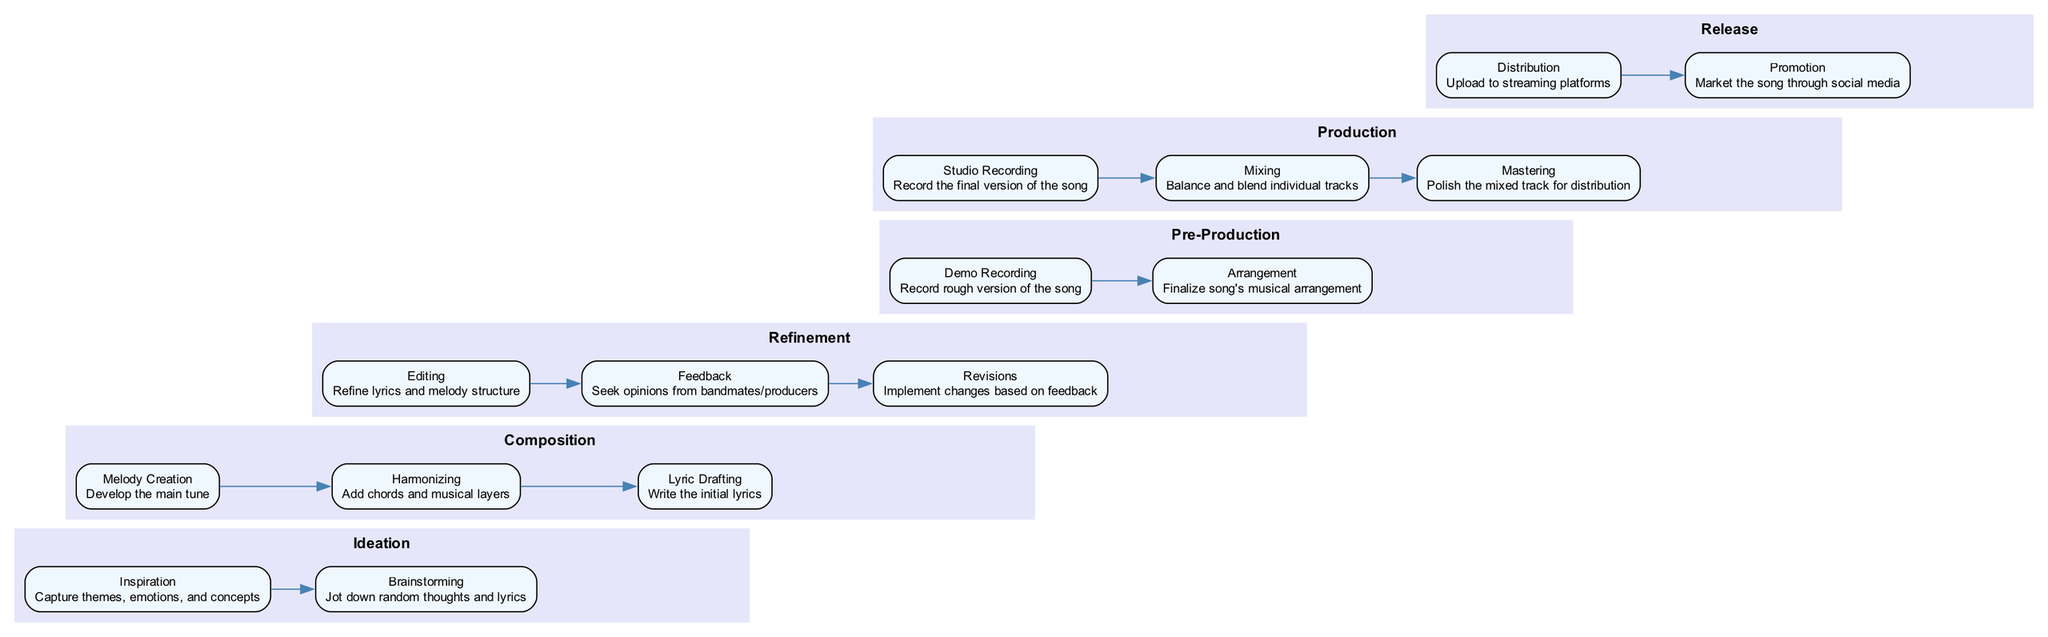What is the first phase in the songwriting process? The timeline begins with the "Ideation" phase, which is the initial stage of the songwriting process.
Answer: Ideation How many milestones are there in the Composition phase? In the Composition phase, there are three milestones: Melody Creation, Harmonizing, and Lyric Drafting. Counting these gives a total of three milestones.
Answer: 3 What is the last milestone in the Production phase? The final milestone listed in the Production phase is "Mastering", which is the step that involves polishing the mixed track for distribution.
Answer: Mastering Which phase includes the milestone "Demo Recording"? The milestone "Demo Recording" is part of the Pre-Production phase, where the rough version of the song is recorded.
Answer: Pre-Production What are the two milestones in the Release phase? The two milestones in the Release phase are "Distribution," which involves uploading to streaming platforms, and "Promotion," which focuses on marketing the song through social media.
Answer: Distribution, Promotion How many phases are there in total on the timeline? There are a total of six phases on the timeline: Ideation, Composition, Refinement, Pre-Production, Production, and Release. Adding these phases gives a total of six.
Answer: 6 Which milestone comes after "Editing" in the Refinement phase? After "Editing," the next milestone listed is "Feedback," where opinions are sought from bandmates or producers.
Answer: Feedback What is the relationship between the Composition and Refinement phases? The Composition phase precedes the Refinement phase in the timeline, indicating a sequential relationship where composition is completed before refinement begins.
Answer: Sequential What is the main focus of the Ideation phase? The main focus of the Ideation phase is to capture themes, emotions, and concepts that will inspire the songwriting process.
Answer: Capture themes, emotions, and concepts 